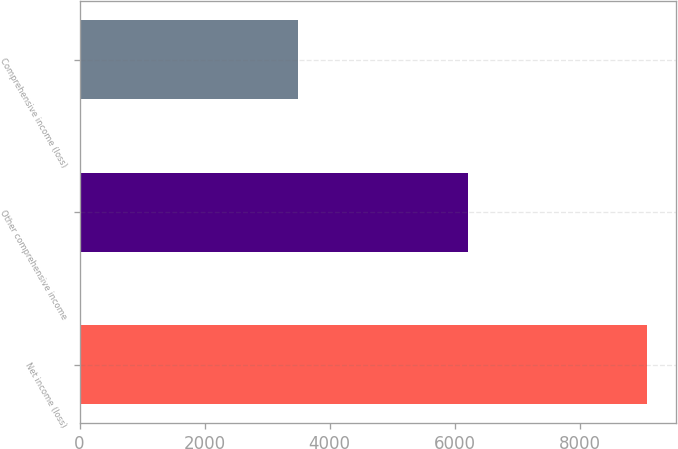Convert chart. <chart><loc_0><loc_0><loc_500><loc_500><bar_chart><fcel>Net income (loss)<fcel>Other comprehensive income<fcel>Comprehensive income (loss)<nl><fcel>9085<fcel>6214<fcel>3492.4<nl></chart> 